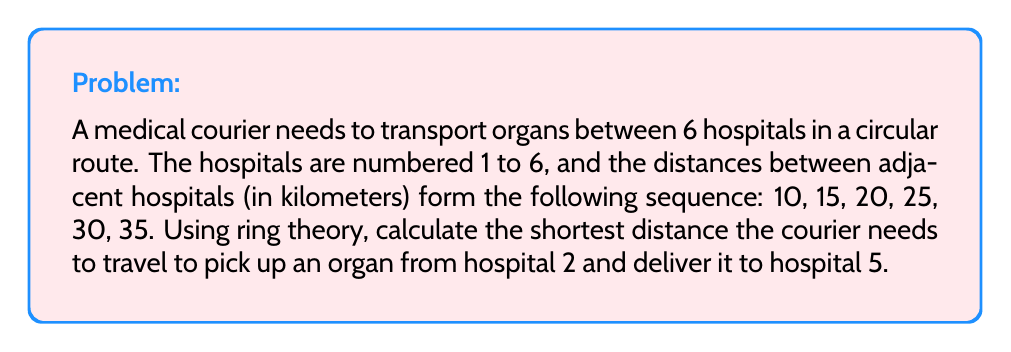Can you answer this question? Let's approach this problem using ring theory:

1) First, we need to represent our circular route as a ring. Let $R$ be the ring of integers modulo 6, i.e., $R = \mathbb{Z}/6\mathbb{Z}$.

2) The elements of $R$ represent the hospitals: $\{0, 1, 2, 3, 4, 5\}$, where 0 corresponds to hospital 6.

3) The distances between adjacent hospitals can be represented as a function $d: R \to \mathbb{Z}$:
   $$d(x) = 5x + 10 \quad \text{(mod 6)}$$

4) To find the distance between any two hospitals $a$ and $b$, we can use the formula:
   $$D(a,b) = \min\left(\sum_{i=a}^{b-1} d(i), \sum_{i=b}^{a-1} d(i)\right) \quad \text{(mod 6)}$$

5) In our case, we need to calculate $D(2,5)$:

   Clockwise: $\sum_{i=2}^{4} d(i) = d(2) + d(3) + d(4) = 20 + 25 + 30 = 75$

   Counterclockwise: $\sum_{i=5}^{1} d(i) = d(5) + d(0) + d(1) = 35 + 10 + 15 = 60$

6) The shorter distance is 60 km, which is the counterclockwise route.

Therefore, the shortest distance for the courier to travel from hospital 2 to hospital 5 is 60 km.
Answer: 60 km 